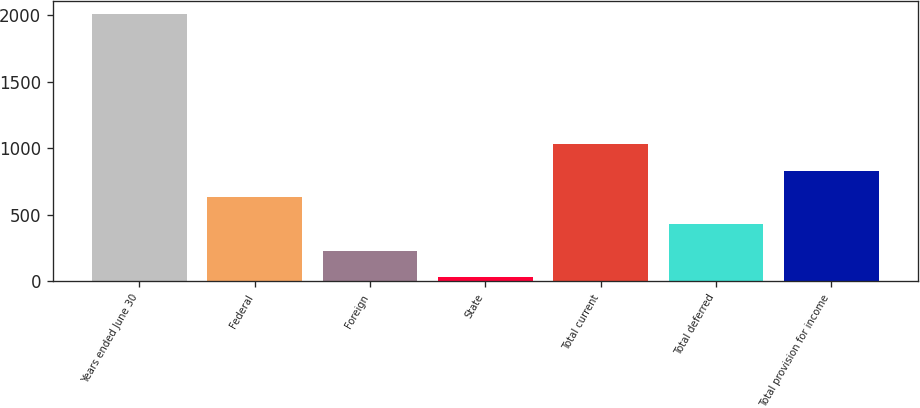Convert chart to OTSL. <chart><loc_0><loc_0><loc_500><loc_500><bar_chart><fcel>Years ended June 30<fcel>Federal<fcel>Foreign<fcel>State<fcel>Total current<fcel>Total deferred<fcel>Total provision for income<nl><fcel>2008<fcel>632.3<fcel>229.15<fcel>31.5<fcel>1027.6<fcel>426.8<fcel>829.95<nl></chart> 